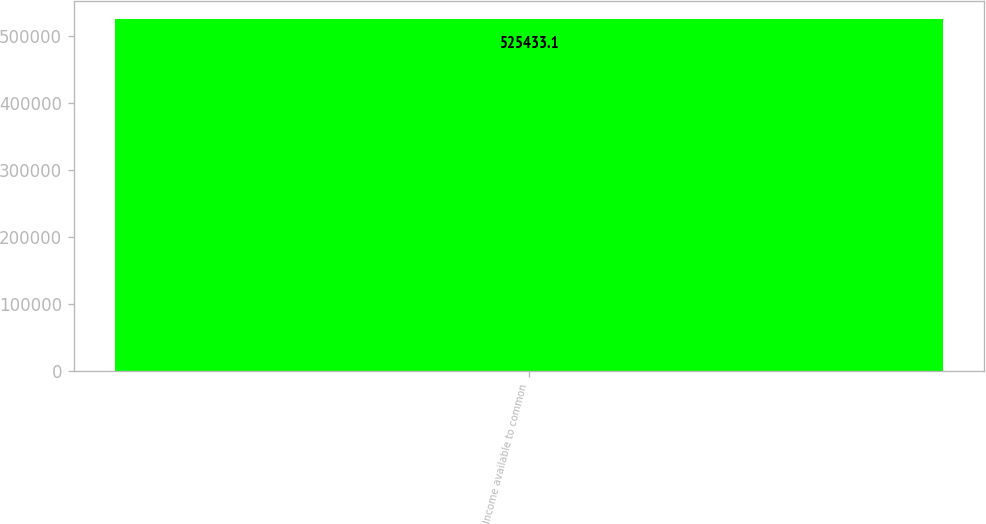Convert chart. <chart><loc_0><loc_0><loc_500><loc_500><bar_chart><fcel>Income available to common<nl><fcel>525433<nl></chart> 